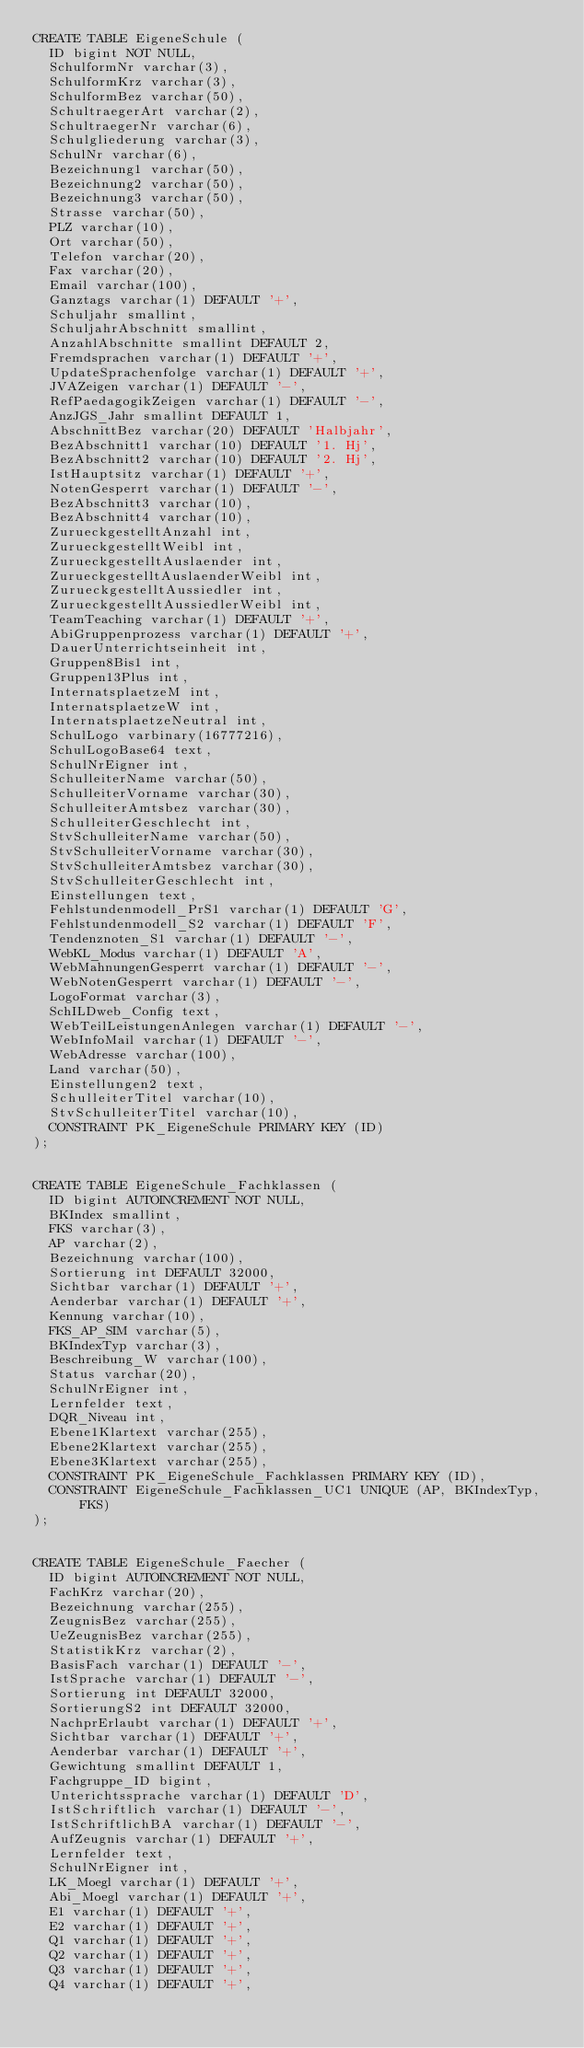<code> <loc_0><loc_0><loc_500><loc_500><_SQL_>CREATE TABLE EigeneSchule (
  ID bigint NOT NULL, 
  SchulformNr varchar(3), 
  SchulformKrz varchar(3), 
  SchulformBez varchar(50), 
  SchultraegerArt varchar(2), 
  SchultraegerNr varchar(6), 
  Schulgliederung varchar(3), 
  SchulNr varchar(6), 
  Bezeichnung1 varchar(50), 
  Bezeichnung2 varchar(50), 
  Bezeichnung3 varchar(50), 
  Strasse varchar(50), 
  PLZ varchar(10), 
  Ort varchar(50), 
  Telefon varchar(20), 
  Fax varchar(20), 
  Email varchar(100), 
  Ganztags varchar(1) DEFAULT '+', 
  Schuljahr smallint, 
  SchuljahrAbschnitt smallint, 
  AnzahlAbschnitte smallint DEFAULT 2, 
  Fremdsprachen varchar(1) DEFAULT '+', 
  UpdateSprachenfolge varchar(1) DEFAULT '+', 
  JVAZeigen varchar(1) DEFAULT '-', 
  RefPaedagogikZeigen varchar(1) DEFAULT '-', 
  AnzJGS_Jahr smallint DEFAULT 1, 
  AbschnittBez varchar(20) DEFAULT 'Halbjahr', 
  BezAbschnitt1 varchar(10) DEFAULT '1. Hj', 
  BezAbschnitt2 varchar(10) DEFAULT '2. Hj', 
  IstHauptsitz varchar(1) DEFAULT '+', 
  NotenGesperrt varchar(1) DEFAULT '-', 
  BezAbschnitt3 varchar(10), 
  BezAbschnitt4 varchar(10), 
  ZurueckgestelltAnzahl int, 
  ZurueckgestelltWeibl int, 
  ZurueckgestelltAuslaender int, 
  ZurueckgestelltAuslaenderWeibl int, 
  ZurueckgestelltAussiedler int, 
  ZurueckgestelltAussiedlerWeibl int, 
  TeamTeaching varchar(1) DEFAULT '+', 
  AbiGruppenprozess varchar(1) DEFAULT '+', 
  DauerUnterrichtseinheit int, 
  Gruppen8Bis1 int, 
  Gruppen13Plus int, 
  InternatsplaetzeM int, 
  InternatsplaetzeW int, 
  InternatsplaetzeNeutral int, 
  SchulLogo varbinary(16777216), 
  SchulLogoBase64 text, 
  SchulNrEigner int, 
  SchulleiterName varchar(50), 
  SchulleiterVorname varchar(30), 
  SchulleiterAmtsbez varchar(30), 
  SchulleiterGeschlecht int, 
  StvSchulleiterName varchar(50), 
  StvSchulleiterVorname varchar(30), 
  StvSchulleiterAmtsbez varchar(30), 
  StvSchulleiterGeschlecht int, 
  Einstellungen text, 
  Fehlstundenmodell_PrS1 varchar(1) DEFAULT 'G', 
  Fehlstundenmodell_S2 varchar(1) DEFAULT 'F', 
  Tendenznoten_S1 varchar(1) DEFAULT '-', 
  WebKL_Modus varchar(1) DEFAULT 'A', 
  WebMahnungenGesperrt varchar(1) DEFAULT '-', 
  WebNotenGesperrt varchar(1) DEFAULT '-', 
  LogoFormat varchar(3), 
  SchILDweb_Config text, 
  WebTeilLeistungenAnlegen varchar(1) DEFAULT '-', 
  WebInfoMail varchar(1) DEFAULT '-', 
  WebAdresse varchar(100), 
  Land varchar(50), 
  Einstellungen2 text, 
  SchulleiterTitel varchar(10), 
  StvSchulleiterTitel varchar(10),
  CONSTRAINT PK_EigeneSchule PRIMARY KEY (ID)
);


CREATE TABLE EigeneSchule_Fachklassen (
  ID bigint AUTOINCREMENT NOT NULL, 
  BKIndex smallint, 
  FKS varchar(3), 
  AP varchar(2), 
  Bezeichnung varchar(100), 
  Sortierung int DEFAULT 32000, 
  Sichtbar varchar(1) DEFAULT '+', 
  Aenderbar varchar(1) DEFAULT '+', 
  Kennung varchar(10), 
  FKS_AP_SIM varchar(5), 
  BKIndexTyp varchar(3), 
  Beschreibung_W varchar(100), 
  Status varchar(20), 
  SchulNrEigner int, 
  Lernfelder text, 
  DQR_Niveau int, 
  Ebene1Klartext varchar(255), 
  Ebene2Klartext varchar(255), 
  Ebene3Klartext varchar(255),
  CONSTRAINT PK_EigeneSchule_Fachklassen PRIMARY KEY (ID),
  CONSTRAINT EigeneSchule_Fachklassen_UC1 UNIQUE (AP, BKIndexTyp, FKS)
);


CREATE TABLE EigeneSchule_Faecher (
  ID bigint AUTOINCREMENT NOT NULL, 
  FachKrz varchar(20), 
  Bezeichnung varchar(255), 
  ZeugnisBez varchar(255), 
  UeZeugnisBez varchar(255), 
  StatistikKrz varchar(2), 
  BasisFach varchar(1) DEFAULT '-', 
  IstSprache varchar(1) DEFAULT '-', 
  Sortierung int DEFAULT 32000, 
  SortierungS2 int DEFAULT 32000, 
  NachprErlaubt varchar(1) DEFAULT '+', 
  Sichtbar varchar(1) DEFAULT '+', 
  Aenderbar varchar(1) DEFAULT '+', 
  Gewichtung smallint DEFAULT 1, 
  Fachgruppe_ID bigint, 
  Unterichtssprache varchar(1) DEFAULT 'D', 
  IstSchriftlich varchar(1) DEFAULT '-', 
  IstSchriftlichBA varchar(1) DEFAULT '-', 
  AufZeugnis varchar(1) DEFAULT '+', 
  Lernfelder text, 
  SchulNrEigner int, 
  LK_Moegl varchar(1) DEFAULT '+', 
  Abi_Moegl varchar(1) DEFAULT '+', 
  E1 varchar(1) DEFAULT '+', 
  E2 varchar(1) DEFAULT '+', 
  Q1 varchar(1) DEFAULT '+', 
  Q2 varchar(1) DEFAULT '+', 
  Q3 varchar(1) DEFAULT '+', 
  Q4 varchar(1) DEFAULT '+', </code> 